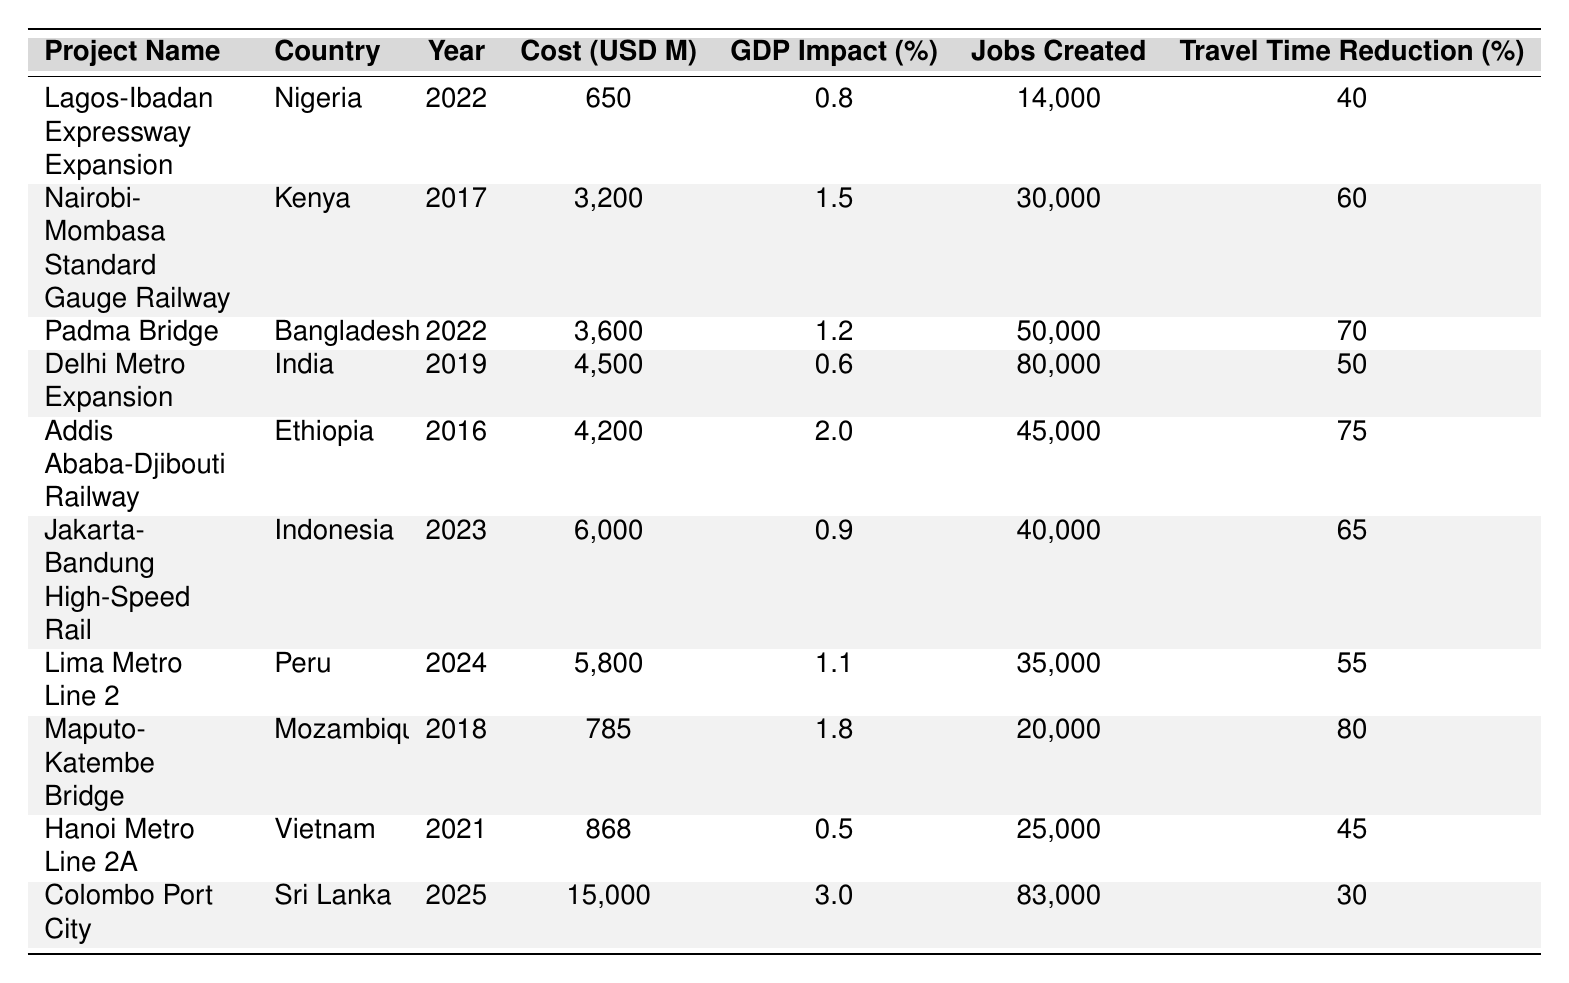What is the total cost of the Padma Bridge project? The table lists the total cost of the Padma Bridge project as 3,600 million USD.
Answer: 3,600 million USD Which project had the highest GDP impact percentage? By examining the GDP impact percentage for each project, the Colombo Port City project has the highest percentage at 3.0%.
Answer: 3.0% How many jobs were created by the Lagos-Ibadan Expressway Expansion project? The Lagos-Ibadan Expressway Expansion project created 14,000 jobs according to the table.
Answer: 14,000 jobs What is the average cost of the infrastructure projects listed? The total cost of all projects is (650 + 3200 + 3600 + 4500 + 4200 + 6000 + 5800 + 785 + 868 + 15000) =  36,800 million USD. There are 10 projects, so the average cost is 36,800 / 10 = 3,680 million USD.
Answer: 3,680 million USD Is there a project that reduced travel time by more than 70%? The travel time reduction percentages are compared and the Padma Bridge and the Maputo-Katembe Bridge reduced travel time by 70% and 80% respectively. Therefore, yes, there are projects that reduced travel time by more than 70%.
Answer: Yes Which country completed a project in 2024, and what was its impact on GDP? Lima Metro Line 2 in Peru is the project that completed in 2024 with a GDP impact of 1.1%.
Answer: Peru, 1.1% Which project provided the second highest number of jobs created? Comparing the job creation figures, the Nairobi-Mombasa Standard Gauge Railway created 30,000 jobs, making it the second highest after Delhi Metro Expansion which created 80,000 jobs.
Answer: Nairobi-Mombasa Standard Gauge Railway What is the total GDP impact percentage of all projects combined? The total GDP impact percentage is the sum of all individual GDP impacts: (0.8 + 1.5 + 1.2 + 0.6 + 2.0 + 0.9 + 1.1 + 1.8 + 0.5 + 3.0) = 13.1%.
Answer: 13.1% Which infrastructure project had the lowest travel time reduction? The Hanoi Metro Line 2A had the lowest travel time reduction at 45%.
Answer: 45% In what year was the Addis Ababa-Djibouti Railway completed and what was its job creation figure? The Addis Ababa-Djibouti Railway was completed in 2016 and created 45,000 jobs.
Answer: 2016, 45,000 jobs 